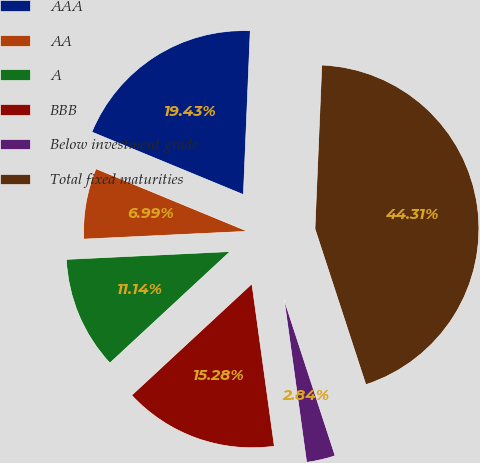Convert chart. <chart><loc_0><loc_0><loc_500><loc_500><pie_chart><fcel>AAA<fcel>AA<fcel>A<fcel>BBB<fcel>Below investment grade<fcel>Total fixed maturities<nl><fcel>19.43%<fcel>6.99%<fcel>11.14%<fcel>15.28%<fcel>2.84%<fcel>44.31%<nl></chart> 